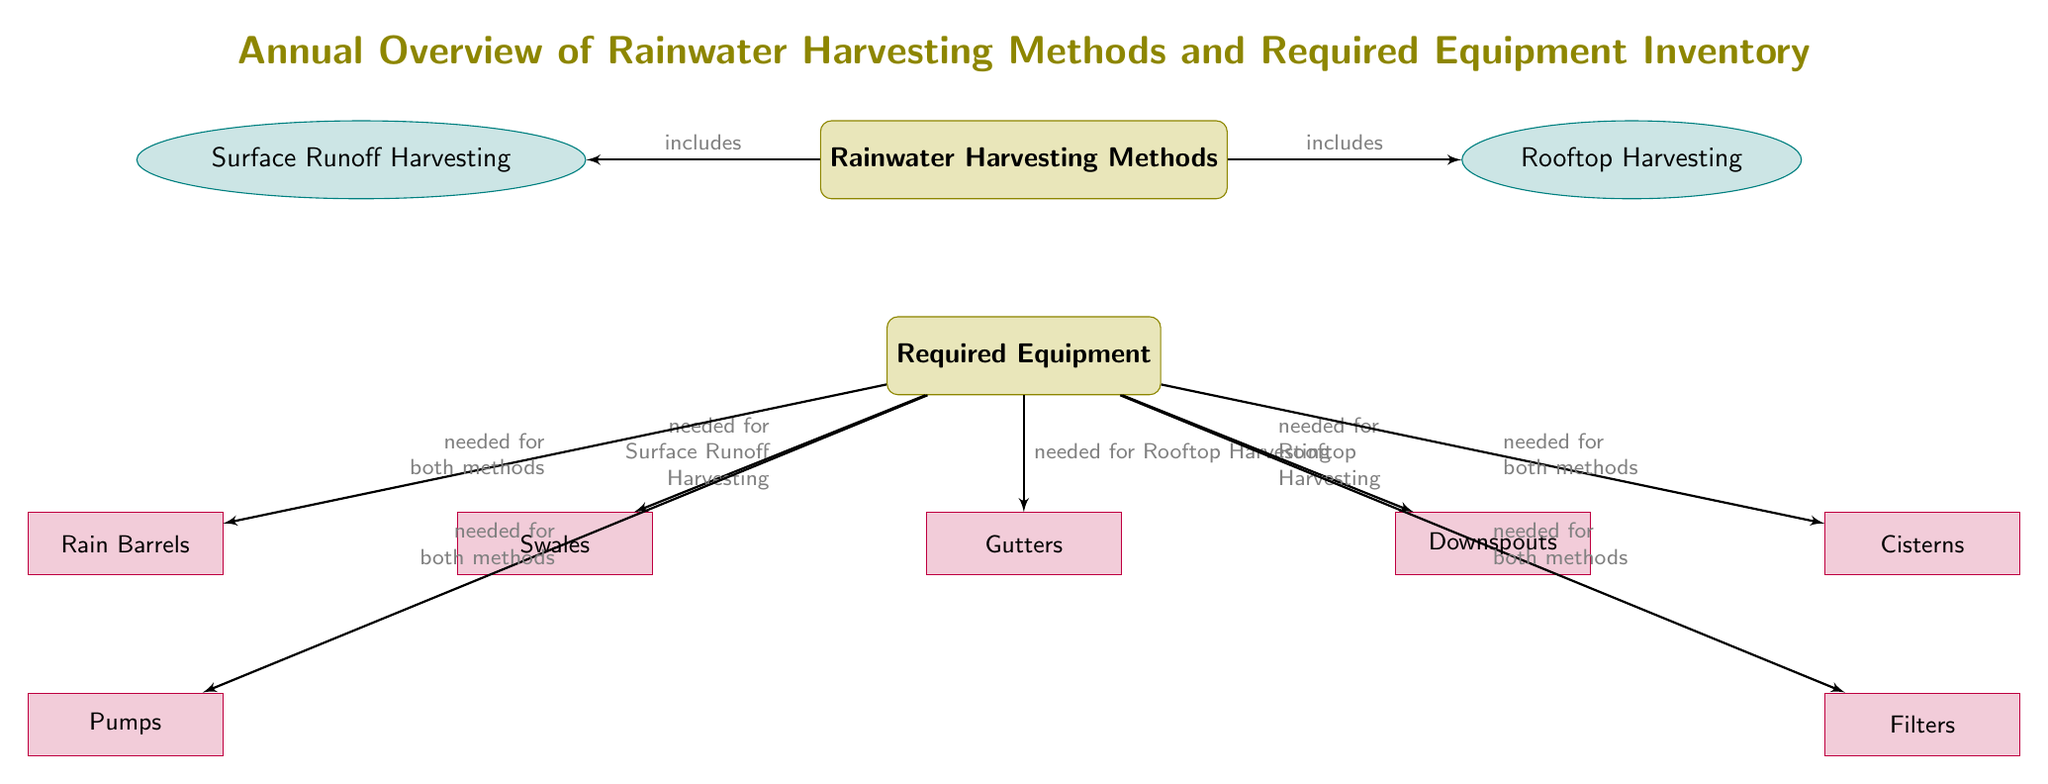What are the two main rainwater harvesting methods listed in the diagram? The diagram identifies two methods under the category of "Rainwater Harvesting Methods": "Surface Runoff Harvesting" and "Rooftop Harvesting."
Answer: Surface Runoff Harvesting, Rooftop Harvesting How many required equipment items are needed for Surface Runoff Harvesting? The diagram shows that "Swales" is the only specific equipment listed under the arrows pointing from "Required Equipment" to "Surface Runoff Harvesting."
Answer: 1 Which equipment is needed for both harvesting methods? "Rain Barrels," "Cisterns," "Pumps," and "Filters" are all indicated by arrows to show they are necessary for both "Surface Runoff Harvesting" and "Rooftop Harvesting."
Answer: Rain Barrels, Cisterns, Pumps, Filters What type of harvesting does the "Gutters" equipment correlate with? The diagram indicates that "Gutters" are directly linked with "Rooftop Harvesting," as shown by the arrow pointing specifically from "Required Equipment" to "Gutters."
Answer: Rooftop Harvesting How many distinct equipment items are shown in the diagram? A total of six distinct equipment items are represented in the diagram: "Swales," "Gutters," "Downspouts," "Rain Barrels," "Cisterns," "Pumps," and "Filters." By counting all these boxes, we get the total.
Answer: 6 Which rainwater harvesting methods require "Downspouts"? The arrow leading from "Required Equipment" to "Downspouts" indicates that it is specifically needed for "Rooftop Harvesting," thus connecting downspouts with that method.
Answer: Rooftop Harvesting What labels or categories are present above the arrows in the diagram? The affirmations displayed by the arrows include the words "includes" and "needed for," indicating the relationship between methods and equipment in the context provided.
Answer: includes, needed for Which category contains the method for harvesting surface runoff? The label "Rainwater Harvesting Methods" contains the method "Surface Runoff Harvesting," clearly associating it with that primary heading.
Answer: Rainwater Harvesting Methods 